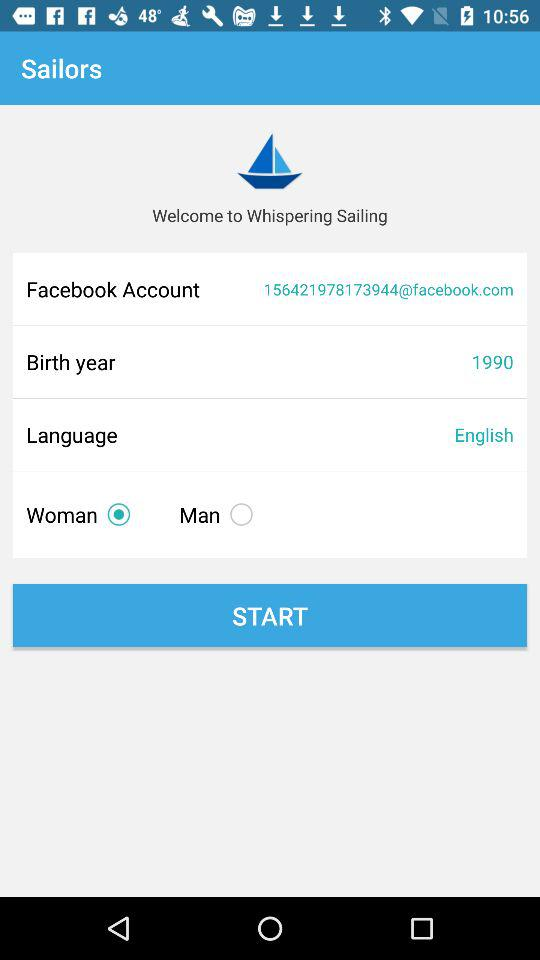Which gender is selected? The selected gender is woman. 